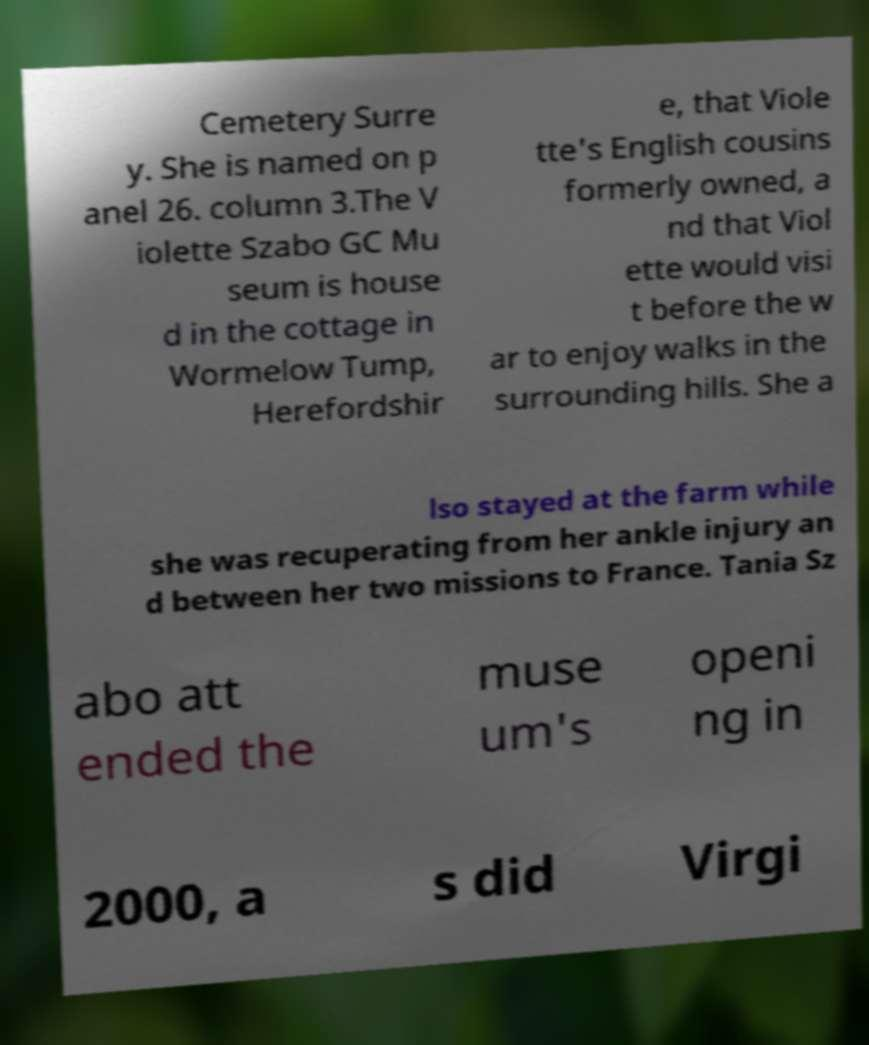What messages or text are displayed in this image? I need them in a readable, typed format. Cemetery Surre y. She is named on p anel 26. column 3.The V iolette Szabo GC Mu seum is house d in the cottage in Wormelow Tump, Herefordshir e, that Viole tte's English cousins formerly owned, a nd that Viol ette would visi t before the w ar to enjoy walks in the surrounding hills. She a lso stayed at the farm while she was recuperating from her ankle injury an d between her two missions to France. Tania Sz abo att ended the muse um's openi ng in 2000, a s did Virgi 